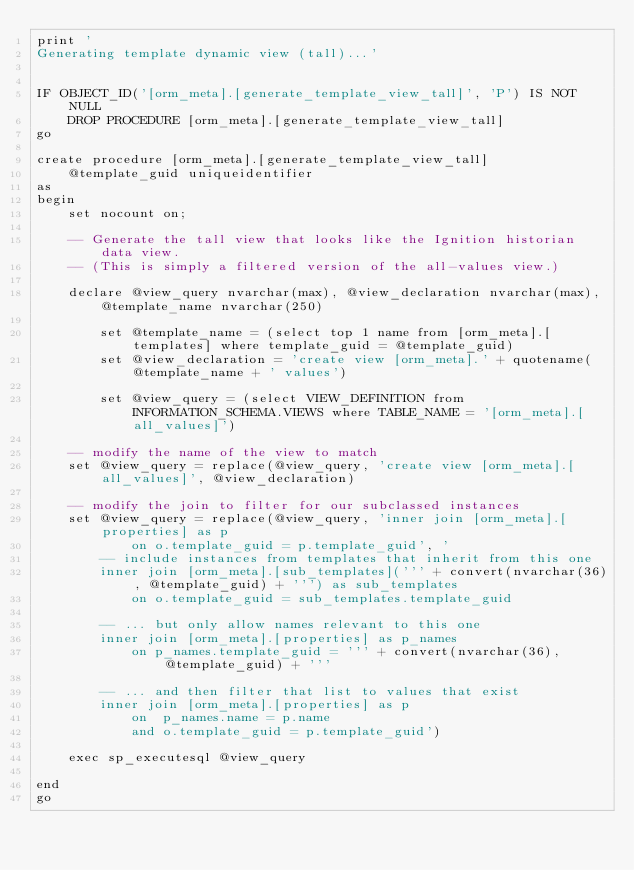<code> <loc_0><loc_0><loc_500><loc_500><_SQL_>print '
Generating template dynamic view (tall)...'


IF OBJECT_ID('[orm_meta].[generate_template_view_tall]', 'P') IS NOT NULL
	DROP PROCEDURE [orm_meta].[generate_template_view_tall]
go

create procedure [orm_meta].[generate_template_view_tall]
	@template_guid uniqueidentifier
as
begin
	set nocount on;

	-- Generate the tall view that looks like the Ignition historian data view.
	-- (This is simply a filtered version of the all-values view.)
	
	declare @view_query nvarchar(max), @view_declaration nvarchar(max), @template_name nvarchar(250)

		set @template_name = (select top 1 name from [orm_meta].[templates] where template_guid = @template_guid)
		set @view_declaration = 'create view [orm_meta].' + quotename(@template_name + ' values')

		set @view_query = (select VIEW_DEFINITION from INFORMATION_SCHEMA.VIEWS	where TABLE_NAME = '[orm_meta].[all_values]')

	-- modify the name of the view to match
	set @view_query = replace(@view_query, 'create view [orm_meta].[all_values]', @view_declaration)

	-- modify the join to filter for our subclassed instances
	set @view_query = replace(@view_query, 'inner join [orm_meta].[properties] as p
			on o.template_guid = p.template_guid', '
		-- include instances from templates that inherit from this one
		inner join [orm_meta].[sub_templates](''' + convert(nvarchar(36), @template_guid) + ''') as sub_templates
			on o.template_guid = sub_templates.template_guid
		
		-- ... but only allow names relevant to this one
		inner join [orm_meta].[properties] as p_names
			on p_names.template_guid = ''' + convert(nvarchar(36), @template_guid) + '''

		-- ... and then filter that list to values that exist
		inner join [orm_meta].[properties] as p
			on	p_names.name = p.name
			and o.template_guid = p.template_guid')

	exec sp_executesql @view_query

end
go









</code> 